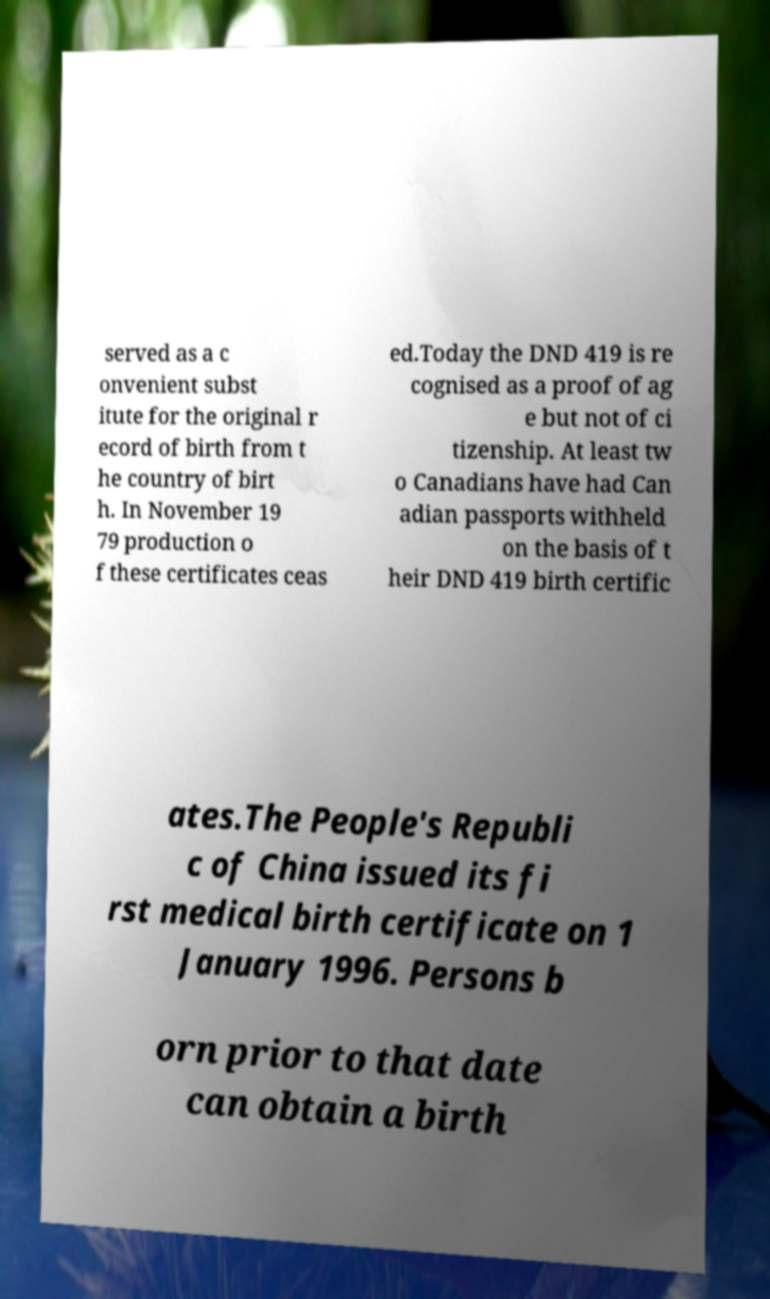Could you extract and type out the text from this image? served as a c onvenient subst itute for the original r ecord of birth from t he country of birt h. In November 19 79 production o f these certificates ceas ed.Today the DND 419 is re cognised as a proof of ag e but not of ci tizenship. At least tw o Canadians have had Can adian passports withheld on the basis of t heir DND 419 birth certific ates.The People's Republi c of China issued its fi rst medical birth certificate on 1 January 1996. Persons b orn prior to that date can obtain a birth 